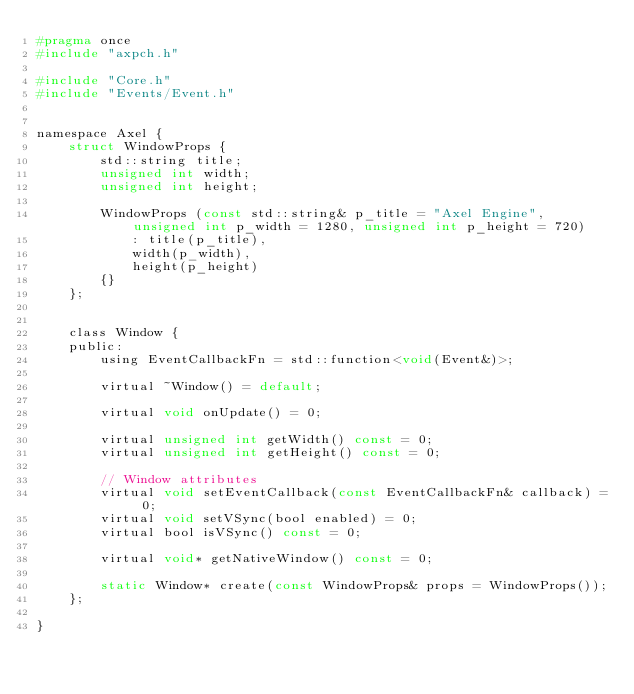<code> <loc_0><loc_0><loc_500><loc_500><_C_>#pragma once
#include "axpch.h"

#include "Core.h"
#include "Events/Event.h"


namespace Axel {
	struct WindowProps {
		std::string title;
		unsigned int width;
		unsigned int height;

		WindowProps (const std::string& p_title = "Axel Engine", unsigned int p_width = 1280, unsigned int p_height = 720)
			: title(p_title),
			width(p_width),
			height(p_height)
		{}
	};


	class Window {
	public:
		using EventCallbackFn = std::function<void(Event&)>;

		virtual ~Window() = default;

		virtual void onUpdate() = 0;

		virtual unsigned int getWidth() const = 0;
		virtual unsigned int getHeight() const = 0;

		// Window attributes
		virtual void setEventCallback(const EventCallbackFn& callback) = 0;
		virtual void setVSync(bool enabled) = 0;
		virtual bool isVSync() const = 0;

		virtual void* getNativeWindow() const = 0;

		static Window* create(const WindowProps& props = WindowProps());
	};

}</code> 